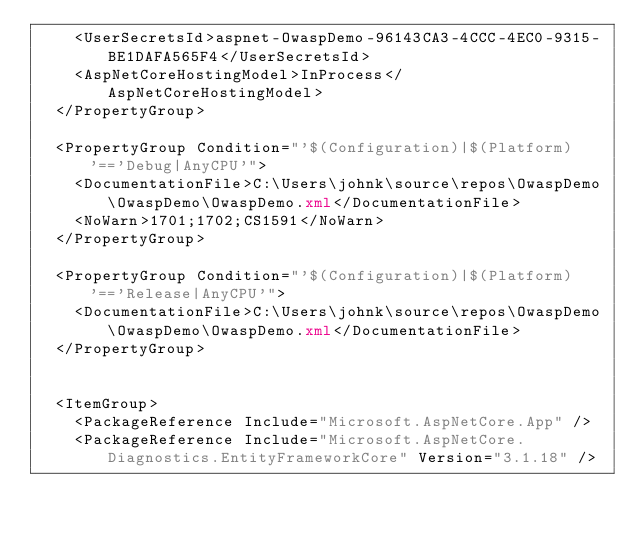<code> <loc_0><loc_0><loc_500><loc_500><_XML_>    <UserSecretsId>aspnet-OwaspDemo-96143CA3-4CCC-4EC0-9315-BE1DAFA565F4</UserSecretsId>
    <AspNetCoreHostingModel>InProcess</AspNetCoreHostingModel>
  </PropertyGroup>

  <PropertyGroup Condition="'$(Configuration)|$(Platform)'=='Debug|AnyCPU'">
    <DocumentationFile>C:\Users\johnk\source\repos\OwaspDemo\OwaspDemo\OwaspDemo.xml</DocumentationFile>
    <NoWarn>1701;1702;CS1591</NoWarn>
  </PropertyGroup>

  <PropertyGroup Condition="'$(Configuration)|$(Platform)'=='Release|AnyCPU'">
    <DocumentationFile>C:\Users\johnk\source\repos\OwaspDemo\OwaspDemo\OwaspDemo.xml</DocumentationFile>
  </PropertyGroup>


  <ItemGroup>
    <PackageReference Include="Microsoft.AspNetCore.App" />
    <PackageReference Include="Microsoft.AspNetCore.Diagnostics.EntityFrameworkCore" Version="3.1.18" /></code> 